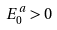<formula> <loc_0><loc_0><loc_500><loc_500>E _ { 0 } ^ { a } > 0</formula> 